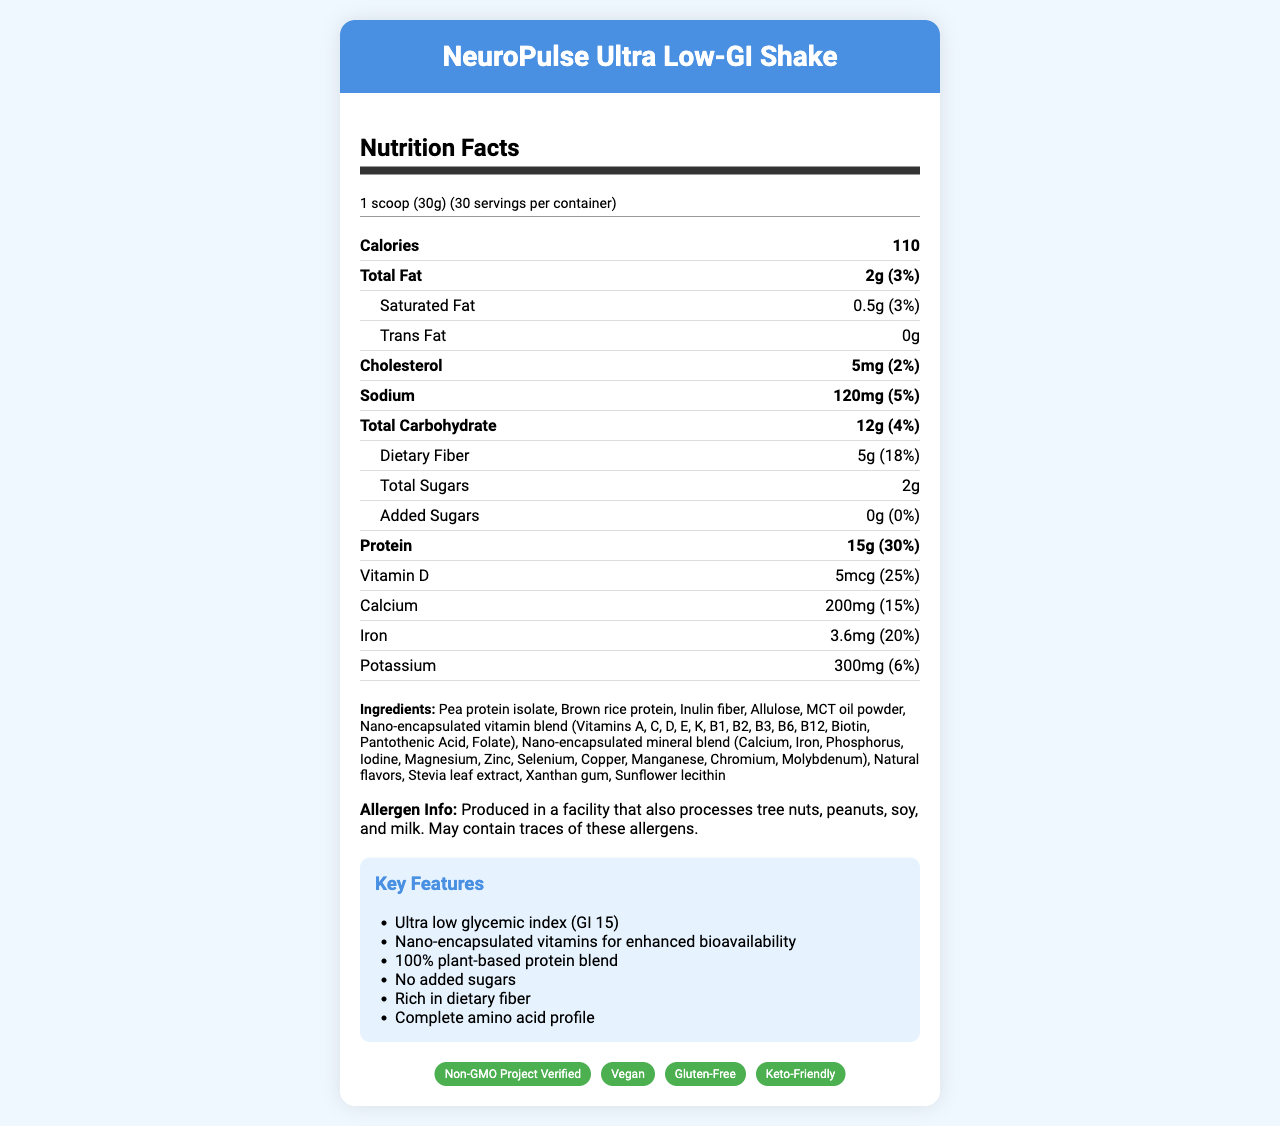what is the serving size for NeuroPulse Ultra Low-GI Shake? The serving size is clearly stated as "1 scoop (30g)" under the nutrition facts section.
Answer: 1 scoop (30g) how many servings are in each container? According to the nutrition facts, there are 30 servings per container.
Answer: 30 what is the total amount of protein per serving? The label lists 15g of protein per serving, which represents 30% of the daily value.
Answer: 15g what is the glycemic index of the product? The key features section highlights the ultra-low glycemic index of the product, specifically noting it is 15.
Answer: 15 how much dietary fiber is there per serving? The nutrition facts state that each serving contains 5g of dietary fiber, contributing 18% to the daily value.
Answer: 5g what are the total calories per serving? A. 50 B. 70 C. 90 D. 110 The nutrition facts indicate there are 110 calories per serving.
Answer: D which of the following certifications apply to NeuroPulse Ultra Low-GI Shake? I. Gluten-Free II. Vegan III. Non-GMO IV. Kosher A. I, II, & III B. I & III C. II & IV D. All of the above The certifications section lists "Non-GMO Project Verified", "Vegan", and "Gluten-Free", but not "Kosher".
Answer: A are there any added sugars in the shake? Based on the nutrition facts, the amount of added sugars is listed as 0g, indicating there are no added sugars.
Answer: No does the product contain any allergens? The allergen info states that it is produced in a facility that also processes tree nuts, peanuts, soy, and milk.
Answer: Yes describe the main features and contents of the NeuroPulse Ultra Low-GI Shake. This summary includes key points from the document such as nutritional information, ingredients, certifications, and product highlights.
Answer: The NeuroPulse Ultra Low-GI Shake is a revolutionary meal replacement shake with a serving size of 30g and 30 servings per container. It has 110 calories per serving, 15g of protein, 5g of dietary fiber, and no added sugars. It contains nano-encapsulated vitamins for enhanced bioavailability and a variety of essential minerals. The shake is 100% plant-based, gluten-free, vegan, keto-friendly, and has a very low glycemic index of 15. Additionally, it is free from common allergens and produced with cutting-edge technology for optimized nutrient absorption. how much potassium is in each serving of the shake? The nutrition facts list 300mg of potassium per serving, which accounts for 6% of the daily value.
Answer: 300mg is the NeuroPulse Ultra Low-GI Shake keto-friendly? The certifications section confirms the product is keto-friendly.
Answer: Yes when does the shake expire if stored in ideal conditions? The shelf life stated in the document is 18 months when stored in a cool, dry place.
Answer: 18 months how does the Nano-encapsulated vitamin blend enhance the shake? The document mentions nano-encapsulation enhances nutrient absorption but does not provide detailed mechanisms.
Answer: Not enough information 